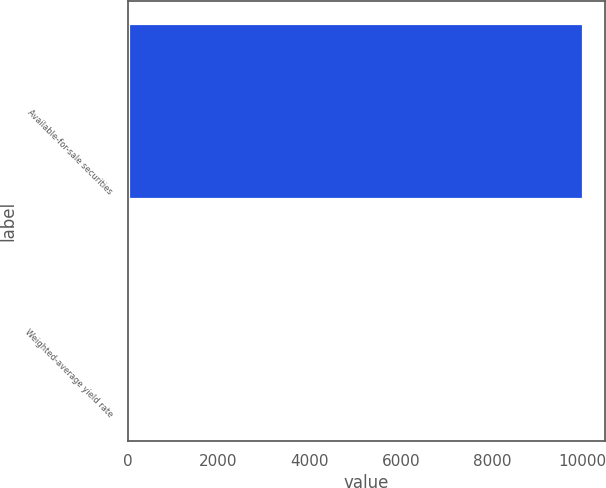<chart> <loc_0><loc_0><loc_500><loc_500><bar_chart><fcel>Available-for-sale securities<fcel>Weighted-average yield rate<nl><fcel>9995<fcel>1<nl></chart> 